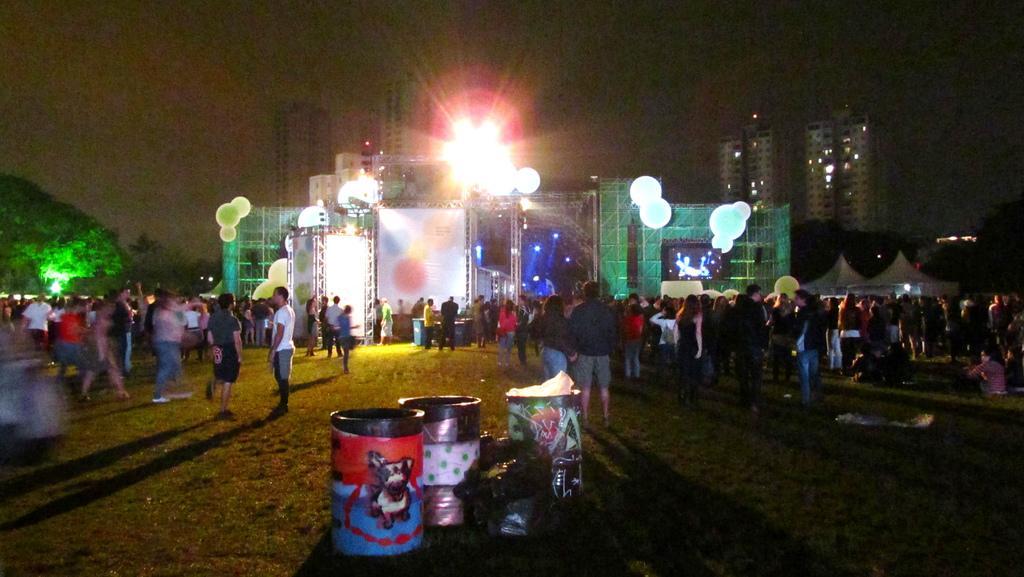Can you describe this image briefly? In this image I can see the group of people standing and wearing the different color dresses. In the front I can see the drums and some objects. In the background I can see the stage with the lights. I can also see many trees, building and sky in the back. 